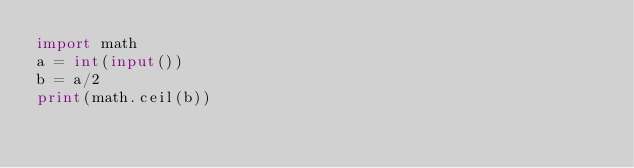<code> <loc_0><loc_0><loc_500><loc_500><_Python_>import math
a = int(input())
b = a/2
print(math.ceil(b))</code> 